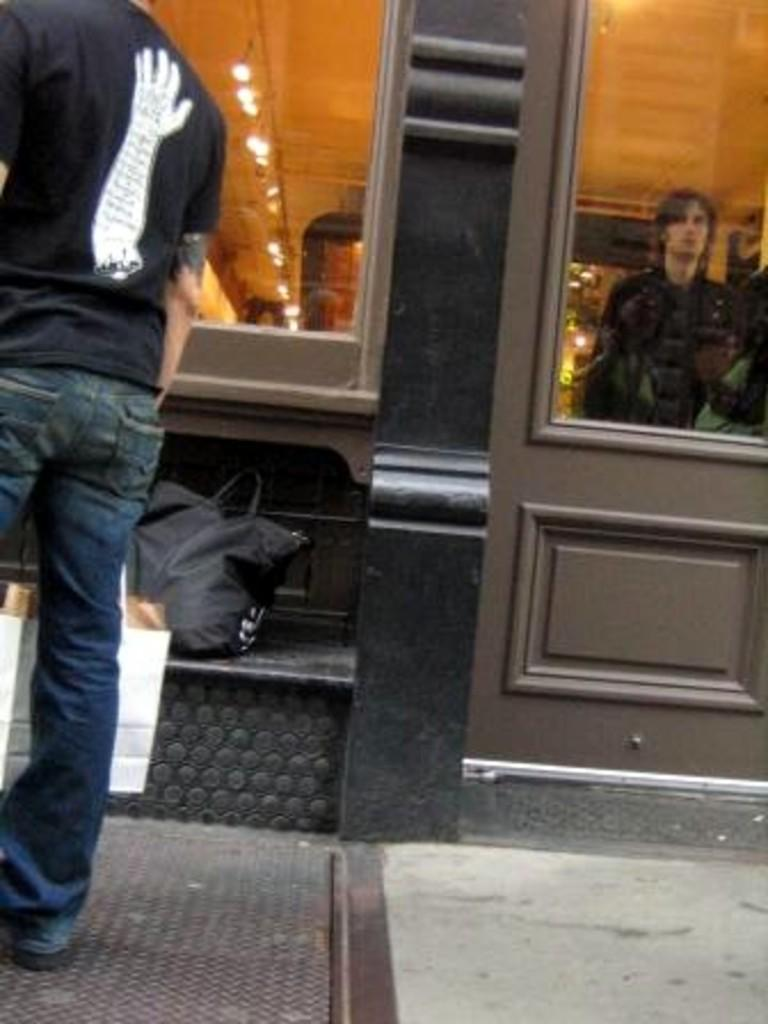What can be seen through the glass in the image? There is a person visible through the glass, and lights are also visible. Can you describe the person visible through the glass? Unfortunately, we cannot see the person's features clearly due to the glass. What is the man on the left side of the image wearing? The man on the left side of the image is wearing a black t-shirt and jeans. What colors are the bags in the image? The bags in the image are in white and black colors. How many beetles can be seen resting on the bags in the image? There are no beetles present in the image. What is the cent value of the currency visible in the image? There is no currency visible in the image. 